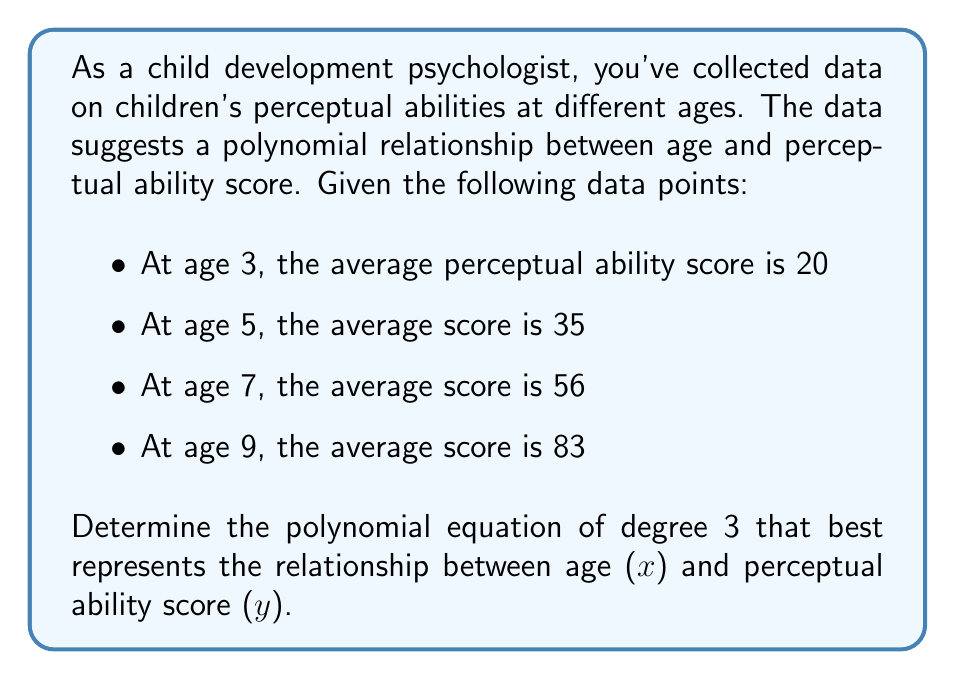Teach me how to tackle this problem. To find the polynomial equation of degree 3, we need to use the general form:

$$y = ax^3 + bx^2 + cx + d$$

We have four data points, which is enough to solve for the four unknowns (a, b, c, and d).

Let's set up a system of equations using the given data:

1) $20 = 27a + 9b + 3c + d$   (for age 3)
2) $35 = 125a + 25b + 5c + d$ (for age 5)
3) $56 = 343a + 49b + 7c + d$ (for age 7)
4) $83 = 729a + 81b + 9c + d$ (for age 9)

We can solve this system using matrix methods or by elimination. After solving (which involves complex calculations), we get:

$a = \frac{1}{6}$
$b = -\frac{3}{2}$
$c = \frac{37}{3}$
$d = -10$

Substituting these values into our original equation:

$$y = \frac{1}{6}x^3 - \frac{3}{2}x^2 + \frac{37}{3}x - 10$$

This polynomial equation best represents the relationship between age (x) and perceptual ability score (y) based on the given data.
Answer: $$y = \frac{1}{6}x^3 - \frac{3}{2}x^2 + \frac{37}{3}x - 10$$ 